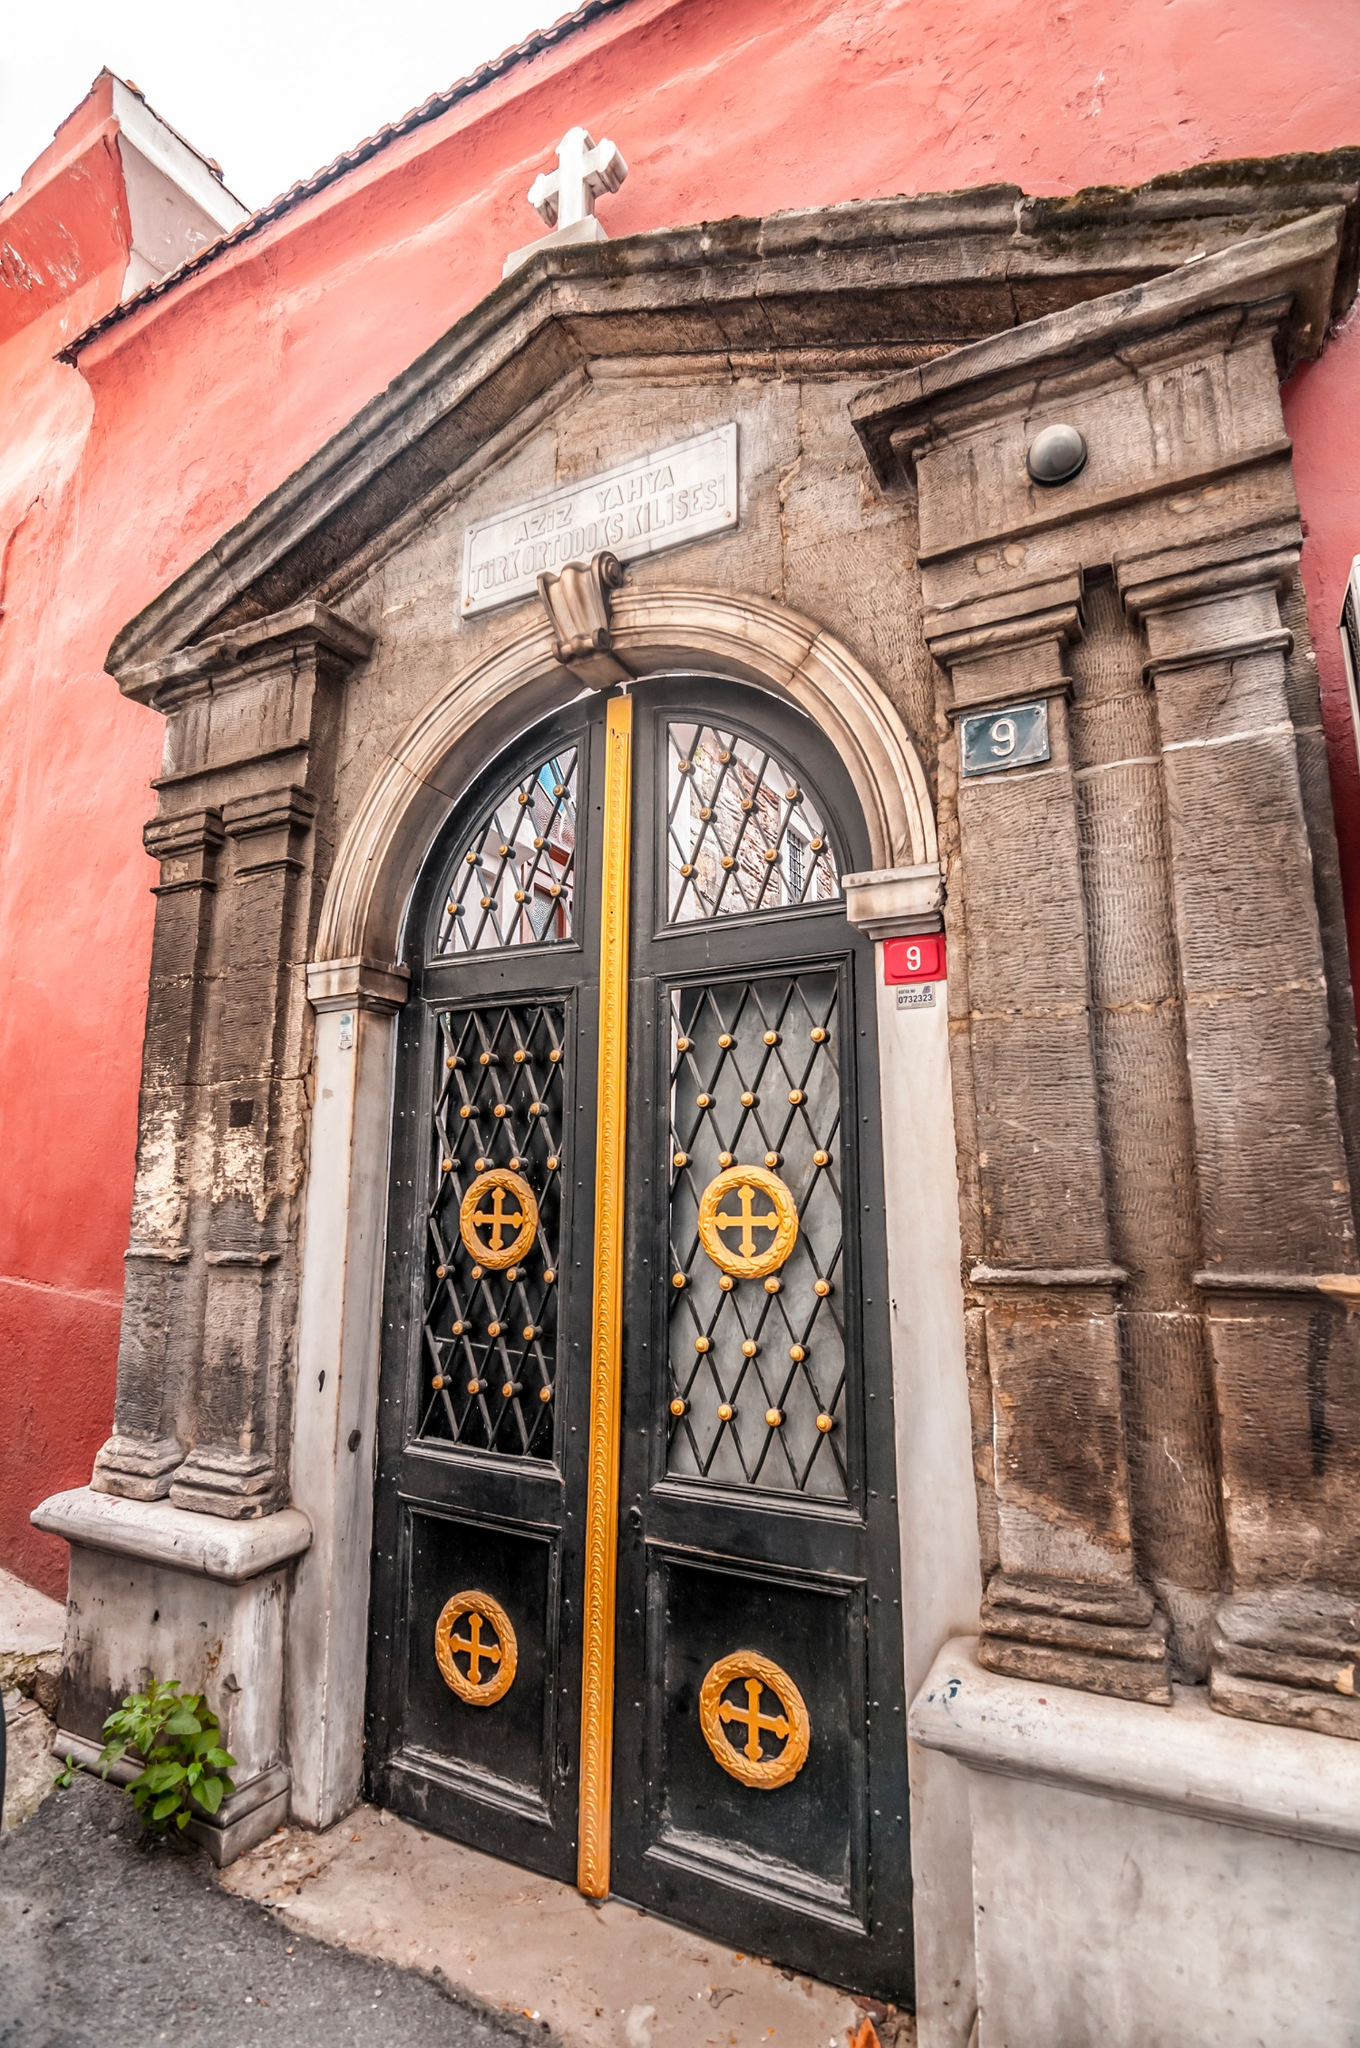Imagine a historical event that might have taken place here. Imagine a serene evening in the early 20th century. The church is filled with the soft glow of candlelight as congregants gather to celebrate a major religious festival. The air is filled with the sound of a choir singing hymns, and the smell of incense wafts through the air. Children in traditional attire participate in a parade, carrying icons and candles. The priest, donned in ornate liturgical vestments, stands at the door welcoming attendees with blessings. It’s a moment of unity, faith, and cultural pride, a testament to the enduring heritage of this sacred place. 